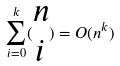<formula> <loc_0><loc_0><loc_500><loc_500>\sum _ { i = 0 } ^ { k } ( \begin{matrix} n \\ i \end{matrix} ) = O ( n ^ { k } )</formula> 